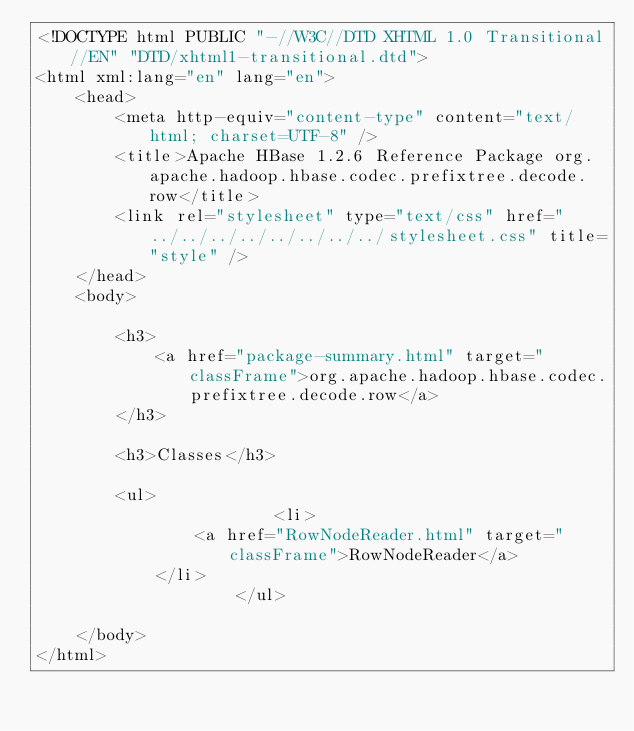Convert code to text. <code><loc_0><loc_0><loc_500><loc_500><_HTML_><!DOCTYPE html PUBLIC "-//W3C//DTD XHTML 1.0 Transitional//EN" "DTD/xhtml1-transitional.dtd">
<html xml:lang="en" lang="en">
	<head>
		<meta http-equiv="content-type" content="text/html; charset=UTF-8" />
		<title>Apache HBase 1.2.6 Reference Package org.apache.hadoop.hbase.codec.prefixtree.decode.row</title>
		<link rel="stylesheet" type="text/css" href="../../../../../../../../stylesheet.css" title="style" />
	</head>
	<body>

		<h3>
        	<a href="package-summary.html" target="classFrame">org.apache.hadoop.hbase.codec.prefixtree.decode.row</a>
      	</h3>

      	<h3>Classes</h3>

      	<ul>
      		          	<li>
            	<a href="RowNodeReader.html" target="classFrame">RowNodeReader</a>
          	</li>
          	      	</ul>

	</body>
</html></code> 